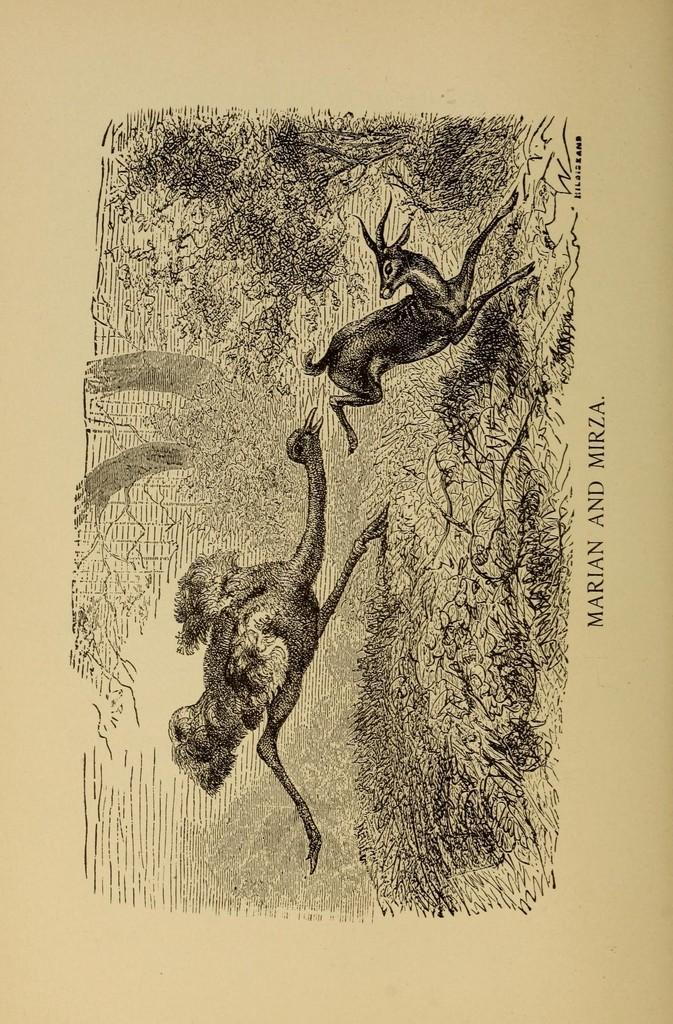What type of animal is depicted in the drawing in the image? There is a drawing of an ostrich in the image. Can you describe the drawing in the image? The drawing in the image is of an animal, specifically an ostrich. What else is present on the image besides the drawing? There is text on the image. What type of vegetable is being advertised by the secretary in the image? There is no secretary or advertisement present in the image, and no vegetable is being advertised. 